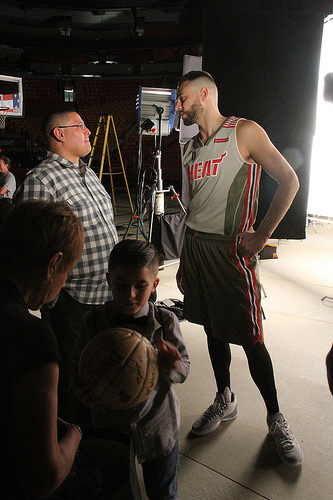<image>
Can you confirm if the player is on the ball? No. The player is not positioned on the ball. They may be near each other, but the player is not supported by or resting on top of the ball. Where is the man in relation to the man? Is it behind the man? Yes. From this viewpoint, the man is positioned behind the man, with the man partially or fully occluding the man. Where is the man in relation to the ball? Is it in front of the ball? No. The man is not in front of the ball. The spatial positioning shows a different relationship between these objects. 